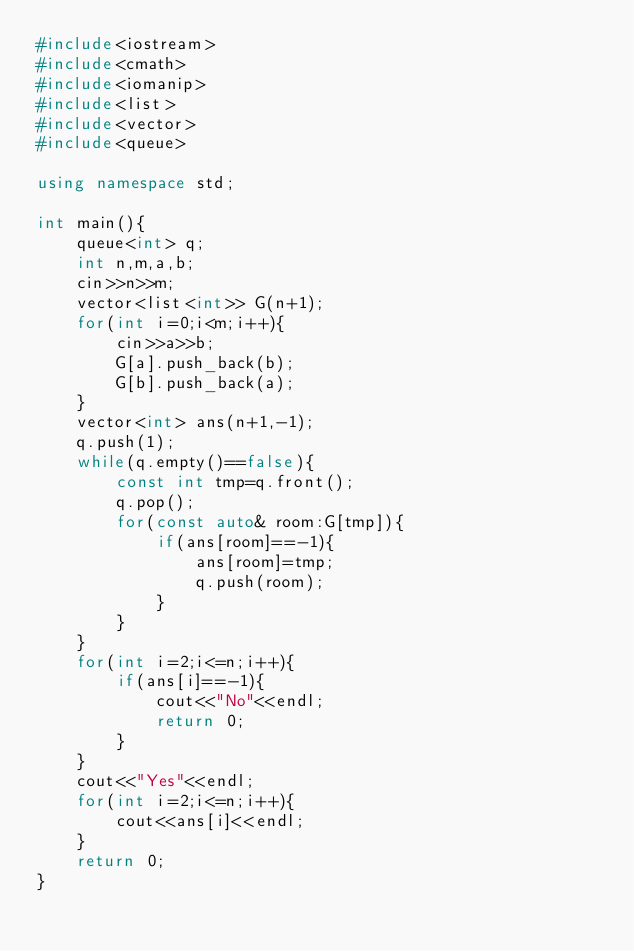<code> <loc_0><loc_0><loc_500><loc_500><_C++_>#include<iostream>
#include<cmath>
#include<iomanip>
#include<list>
#include<vector>
#include<queue>

using namespace std;

int main(){
    queue<int> q;
    int n,m,a,b;
    cin>>n>>m;
    vector<list<int>> G(n+1);
    for(int i=0;i<m;i++){
        cin>>a>>b;
        G[a].push_back(b);
        G[b].push_back(a);
    }
    vector<int> ans(n+1,-1);
    q.push(1);
    while(q.empty()==false){
        const int tmp=q.front();
        q.pop();
        for(const auto& room:G[tmp]){
            if(ans[room]==-1){
                ans[room]=tmp;
                q.push(room);
            }
        }
    }
    for(int i=2;i<=n;i++){
        if(ans[i]==-1){
            cout<<"No"<<endl;
            return 0;
        }
    }
    cout<<"Yes"<<endl;
    for(int i=2;i<=n;i++){
        cout<<ans[i]<<endl;
    }
    return 0;
}</code> 